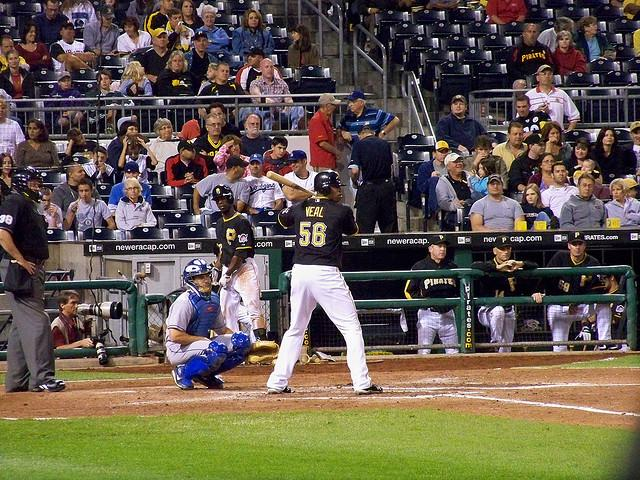What can you obtain from the website advertised? Please explain your reasoning. team hat. New era cap makes sports hats. 